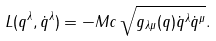Convert formula to latex. <formula><loc_0><loc_0><loc_500><loc_500>L ( q ^ { \lambda } , \dot { q } ^ { \lambda } ) = - M c \, \sqrt { g _ { \lambda \mu } ( q ) \dot { q } ^ { \lambda } \dot { q } ^ { \mu } } .</formula> 